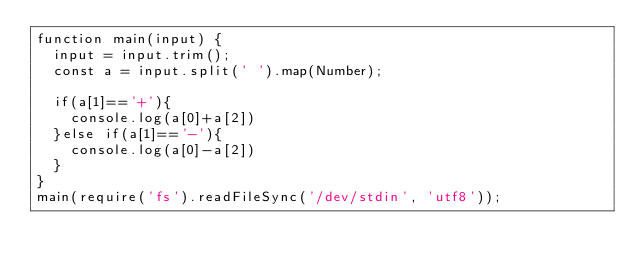Convert code to text. <code><loc_0><loc_0><loc_500><loc_500><_JavaScript_>function main(input) {
  input = input.trim();
  const a = input.split(' ').map(Number);
  
  if(a[1]=='+'){
    console.log(a[0]+a[2])
  }else if(a[1]=='-'){
    console.log(a[0]-a[2])
  }
}
main(require('fs').readFileSync('/dev/stdin', 'utf8'));</code> 